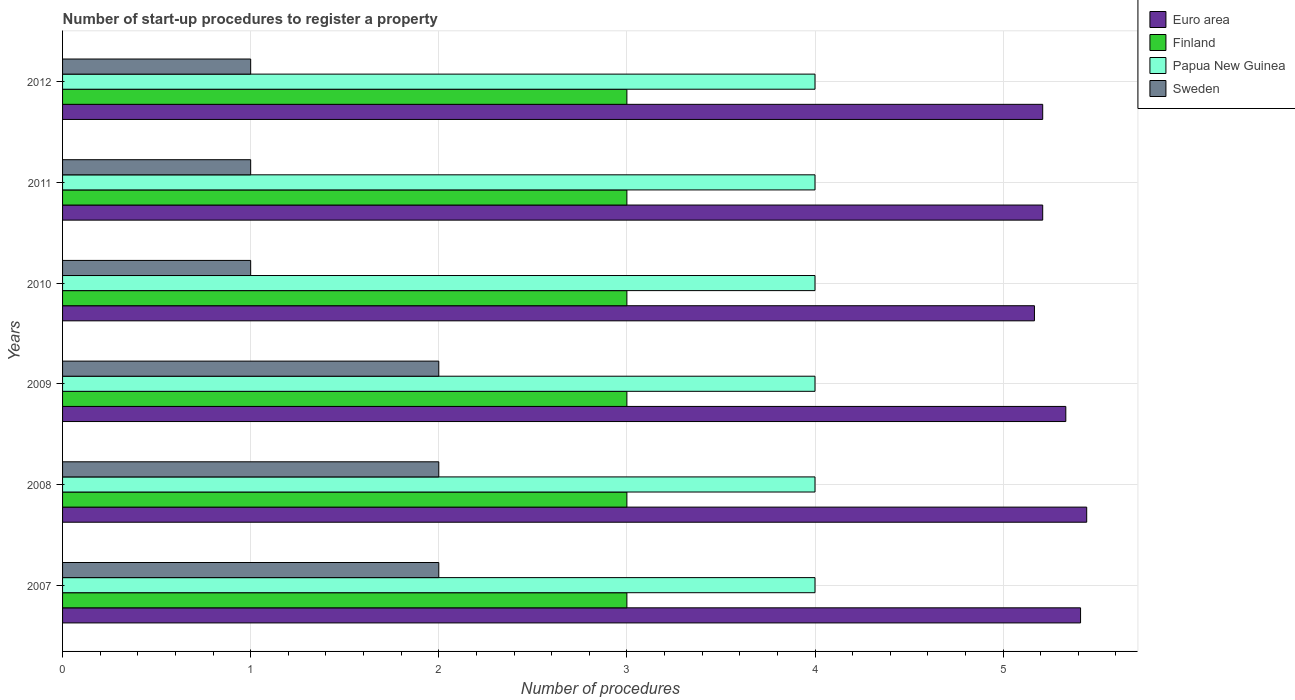How many groups of bars are there?
Make the answer very short. 6. In how many cases, is the number of bars for a given year not equal to the number of legend labels?
Keep it short and to the point. 0. What is the number of procedures required to register a property in Euro area in 2009?
Give a very brief answer. 5.33. Across all years, what is the maximum number of procedures required to register a property in Papua New Guinea?
Provide a succinct answer. 4. Across all years, what is the minimum number of procedures required to register a property in Papua New Guinea?
Your answer should be very brief. 4. In which year was the number of procedures required to register a property in Finland maximum?
Make the answer very short. 2007. What is the total number of procedures required to register a property in Finland in the graph?
Your response must be concise. 18. What is the difference between the number of procedures required to register a property in Sweden in 2010 and the number of procedures required to register a property in Papua New Guinea in 2009?
Your answer should be compact. -3. What is the average number of procedures required to register a property in Euro area per year?
Your response must be concise. 5.3. In the year 2012, what is the difference between the number of procedures required to register a property in Papua New Guinea and number of procedures required to register a property in Finland?
Your answer should be compact. 1. Is the difference between the number of procedures required to register a property in Papua New Guinea in 2008 and 2012 greater than the difference between the number of procedures required to register a property in Finland in 2008 and 2012?
Make the answer very short. No. What is the difference between the highest and the lowest number of procedures required to register a property in Papua New Guinea?
Offer a very short reply. 0. In how many years, is the number of procedures required to register a property in Euro area greater than the average number of procedures required to register a property in Euro area taken over all years?
Give a very brief answer. 3. What does the 3rd bar from the top in 2011 represents?
Provide a short and direct response. Finland. What does the 2nd bar from the bottom in 2012 represents?
Make the answer very short. Finland. Is it the case that in every year, the sum of the number of procedures required to register a property in Sweden and number of procedures required to register a property in Euro area is greater than the number of procedures required to register a property in Finland?
Offer a terse response. Yes. Are all the bars in the graph horizontal?
Your answer should be compact. Yes. How many years are there in the graph?
Offer a very short reply. 6. What is the difference between two consecutive major ticks on the X-axis?
Make the answer very short. 1. Does the graph contain grids?
Provide a short and direct response. Yes. How many legend labels are there?
Your response must be concise. 4. How are the legend labels stacked?
Ensure brevity in your answer.  Vertical. What is the title of the graph?
Offer a terse response. Number of start-up procedures to register a property. What is the label or title of the X-axis?
Give a very brief answer. Number of procedures. What is the Number of procedures of Euro area in 2007?
Your response must be concise. 5.41. What is the Number of procedures in Papua New Guinea in 2007?
Keep it short and to the point. 4. What is the Number of procedures in Euro area in 2008?
Your answer should be very brief. 5.44. What is the Number of procedures in Sweden in 2008?
Keep it short and to the point. 2. What is the Number of procedures in Euro area in 2009?
Provide a short and direct response. 5.33. What is the Number of procedures in Finland in 2009?
Keep it short and to the point. 3. What is the Number of procedures of Papua New Guinea in 2009?
Provide a succinct answer. 4. What is the Number of procedures in Sweden in 2009?
Ensure brevity in your answer.  2. What is the Number of procedures in Euro area in 2010?
Offer a terse response. 5.17. What is the Number of procedures in Finland in 2010?
Your answer should be compact. 3. What is the Number of procedures of Papua New Guinea in 2010?
Provide a short and direct response. 4. What is the Number of procedures in Sweden in 2010?
Offer a very short reply. 1. What is the Number of procedures of Euro area in 2011?
Keep it short and to the point. 5.21. What is the Number of procedures in Papua New Guinea in 2011?
Make the answer very short. 4. What is the Number of procedures of Sweden in 2011?
Ensure brevity in your answer.  1. What is the Number of procedures in Euro area in 2012?
Your response must be concise. 5.21. What is the Number of procedures in Finland in 2012?
Your answer should be compact. 3. What is the Number of procedures in Papua New Guinea in 2012?
Your response must be concise. 4. Across all years, what is the maximum Number of procedures in Euro area?
Make the answer very short. 5.44. Across all years, what is the maximum Number of procedures in Finland?
Your response must be concise. 3. Across all years, what is the maximum Number of procedures in Sweden?
Provide a short and direct response. 2. Across all years, what is the minimum Number of procedures in Euro area?
Your answer should be very brief. 5.17. Across all years, what is the minimum Number of procedures in Finland?
Give a very brief answer. 3. Across all years, what is the minimum Number of procedures in Sweden?
Provide a succinct answer. 1. What is the total Number of procedures in Euro area in the graph?
Ensure brevity in your answer.  31.78. What is the total Number of procedures in Papua New Guinea in the graph?
Provide a succinct answer. 24. What is the total Number of procedures in Sweden in the graph?
Provide a succinct answer. 9. What is the difference between the Number of procedures of Euro area in 2007 and that in 2008?
Your answer should be compact. -0.03. What is the difference between the Number of procedures of Finland in 2007 and that in 2008?
Keep it short and to the point. 0. What is the difference between the Number of procedures of Papua New Guinea in 2007 and that in 2008?
Your answer should be compact. 0. What is the difference between the Number of procedures of Euro area in 2007 and that in 2009?
Keep it short and to the point. 0.08. What is the difference between the Number of procedures of Euro area in 2007 and that in 2010?
Your answer should be compact. 0.25. What is the difference between the Number of procedures of Finland in 2007 and that in 2010?
Ensure brevity in your answer.  0. What is the difference between the Number of procedures of Sweden in 2007 and that in 2010?
Your response must be concise. 1. What is the difference between the Number of procedures in Euro area in 2007 and that in 2011?
Ensure brevity in your answer.  0.2. What is the difference between the Number of procedures of Papua New Guinea in 2007 and that in 2011?
Your answer should be very brief. 0. What is the difference between the Number of procedures of Sweden in 2007 and that in 2011?
Make the answer very short. 1. What is the difference between the Number of procedures in Euro area in 2007 and that in 2012?
Provide a short and direct response. 0.2. What is the difference between the Number of procedures in Euro area in 2008 and that in 2009?
Keep it short and to the point. 0.11. What is the difference between the Number of procedures in Finland in 2008 and that in 2009?
Offer a terse response. 0. What is the difference between the Number of procedures of Papua New Guinea in 2008 and that in 2009?
Make the answer very short. 0. What is the difference between the Number of procedures of Sweden in 2008 and that in 2009?
Provide a short and direct response. 0. What is the difference between the Number of procedures in Euro area in 2008 and that in 2010?
Offer a terse response. 0.28. What is the difference between the Number of procedures of Sweden in 2008 and that in 2010?
Your answer should be very brief. 1. What is the difference between the Number of procedures of Euro area in 2008 and that in 2011?
Make the answer very short. 0.23. What is the difference between the Number of procedures in Papua New Guinea in 2008 and that in 2011?
Ensure brevity in your answer.  0. What is the difference between the Number of procedures in Sweden in 2008 and that in 2011?
Make the answer very short. 1. What is the difference between the Number of procedures of Euro area in 2008 and that in 2012?
Your answer should be compact. 0.23. What is the difference between the Number of procedures of Papua New Guinea in 2009 and that in 2010?
Ensure brevity in your answer.  0. What is the difference between the Number of procedures of Euro area in 2009 and that in 2011?
Provide a succinct answer. 0.12. What is the difference between the Number of procedures of Finland in 2009 and that in 2011?
Provide a succinct answer. 0. What is the difference between the Number of procedures of Sweden in 2009 and that in 2011?
Offer a terse response. 1. What is the difference between the Number of procedures in Euro area in 2009 and that in 2012?
Keep it short and to the point. 0.12. What is the difference between the Number of procedures in Finland in 2009 and that in 2012?
Provide a succinct answer. 0. What is the difference between the Number of procedures in Sweden in 2009 and that in 2012?
Provide a succinct answer. 1. What is the difference between the Number of procedures of Euro area in 2010 and that in 2011?
Keep it short and to the point. -0.04. What is the difference between the Number of procedures of Finland in 2010 and that in 2011?
Your response must be concise. 0. What is the difference between the Number of procedures of Papua New Guinea in 2010 and that in 2011?
Provide a succinct answer. 0. What is the difference between the Number of procedures of Euro area in 2010 and that in 2012?
Give a very brief answer. -0.04. What is the difference between the Number of procedures of Finland in 2010 and that in 2012?
Offer a terse response. 0. What is the difference between the Number of procedures in Papua New Guinea in 2010 and that in 2012?
Provide a succinct answer. 0. What is the difference between the Number of procedures in Sweden in 2010 and that in 2012?
Provide a succinct answer. 0. What is the difference between the Number of procedures of Finland in 2011 and that in 2012?
Offer a terse response. 0. What is the difference between the Number of procedures of Papua New Guinea in 2011 and that in 2012?
Ensure brevity in your answer.  0. What is the difference between the Number of procedures of Euro area in 2007 and the Number of procedures of Finland in 2008?
Make the answer very short. 2.41. What is the difference between the Number of procedures in Euro area in 2007 and the Number of procedures in Papua New Guinea in 2008?
Your answer should be compact. 1.41. What is the difference between the Number of procedures in Euro area in 2007 and the Number of procedures in Sweden in 2008?
Give a very brief answer. 3.41. What is the difference between the Number of procedures in Papua New Guinea in 2007 and the Number of procedures in Sweden in 2008?
Ensure brevity in your answer.  2. What is the difference between the Number of procedures in Euro area in 2007 and the Number of procedures in Finland in 2009?
Give a very brief answer. 2.41. What is the difference between the Number of procedures of Euro area in 2007 and the Number of procedures of Papua New Guinea in 2009?
Keep it short and to the point. 1.41. What is the difference between the Number of procedures in Euro area in 2007 and the Number of procedures in Sweden in 2009?
Make the answer very short. 3.41. What is the difference between the Number of procedures in Finland in 2007 and the Number of procedures in Sweden in 2009?
Provide a short and direct response. 1. What is the difference between the Number of procedures in Papua New Guinea in 2007 and the Number of procedures in Sweden in 2009?
Your response must be concise. 2. What is the difference between the Number of procedures in Euro area in 2007 and the Number of procedures in Finland in 2010?
Offer a terse response. 2.41. What is the difference between the Number of procedures in Euro area in 2007 and the Number of procedures in Papua New Guinea in 2010?
Offer a very short reply. 1.41. What is the difference between the Number of procedures of Euro area in 2007 and the Number of procedures of Sweden in 2010?
Ensure brevity in your answer.  4.41. What is the difference between the Number of procedures of Finland in 2007 and the Number of procedures of Papua New Guinea in 2010?
Ensure brevity in your answer.  -1. What is the difference between the Number of procedures of Finland in 2007 and the Number of procedures of Sweden in 2010?
Your answer should be compact. 2. What is the difference between the Number of procedures of Euro area in 2007 and the Number of procedures of Finland in 2011?
Offer a terse response. 2.41. What is the difference between the Number of procedures of Euro area in 2007 and the Number of procedures of Papua New Guinea in 2011?
Give a very brief answer. 1.41. What is the difference between the Number of procedures of Euro area in 2007 and the Number of procedures of Sweden in 2011?
Make the answer very short. 4.41. What is the difference between the Number of procedures in Finland in 2007 and the Number of procedures in Sweden in 2011?
Offer a very short reply. 2. What is the difference between the Number of procedures of Euro area in 2007 and the Number of procedures of Finland in 2012?
Provide a short and direct response. 2.41. What is the difference between the Number of procedures of Euro area in 2007 and the Number of procedures of Papua New Guinea in 2012?
Provide a succinct answer. 1.41. What is the difference between the Number of procedures in Euro area in 2007 and the Number of procedures in Sweden in 2012?
Your response must be concise. 4.41. What is the difference between the Number of procedures in Euro area in 2008 and the Number of procedures in Finland in 2009?
Keep it short and to the point. 2.44. What is the difference between the Number of procedures of Euro area in 2008 and the Number of procedures of Papua New Guinea in 2009?
Ensure brevity in your answer.  1.44. What is the difference between the Number of procedures of Euro area in 2008 and the Number of procedures of Sweden in 2009?
Give a very brief answer. 3.44. What is the difference between the Number of procedures of Finland in 2008 and the Number of procedures of Sweden in 2009?
Ensure brevity in your answer.  1. What is the difference between the Number of procedures in Euro area in 2008 and the Number of procedures in Finland in 2010?
Your answer should be compact. 2.44. What is the difference between the Number of procedures of Euro area in 2008 and the Number of procedures of Papua New Guinea in 2010?
Give a very brief answer. 1.44. What is the difference between the Number of procedures of Euro area in 2008 and the Number of procedures of Sweden in 2010?
Provide a succinct answer. 4.44. What is the difference between the Number of procedures of Papua New Guinea in 2008 and the Number of procedures of Sweden in 2010?
Keep it short and to the point. 3. What is the difference between the Number of procedures of Euro area in 2008 and the Number of procedures of Finland in 2011?
Give a very brief answer. 2.44. What is the difference between the Number of procedures of Euro area in 2008 and the Number of procedures of Papua New Guinea in 2011?
Ensure brevity in your answer.  1.44. What is the difference between the Number of procedures in Euro area in 2008 and the Number of procedures in Sweden in 2011?
Your response must be concise. 4.44. What is the difference between the Number of procedures in Finland in 2008 and the Number of procedures in Papua New Guinea in 2011?
Give a very brief answer. -1. What is the difference between the Number of procedures of Euro area in 2008 and the Number of procedures of Finland in 2012?
Make the answer very short. 2.44. What is the difference between the Number of procedures in Euro area in 2008 and the Number of procedures in Papua New Guinea in 2012?
Offer a very short reply. 1.44. What is the difference between the Number of procedures of Euro area in 2008 and the Number of procedures of Sweden in 2012?
Your answer should be very brief. 4.44. What is the difference between the Number of procedures of Finland in 2008 and the Number of procedures of Sweden in 2012?
Your answer should be compact. 2. What is the difference between the Number of procedures in Papua New Guinea in 2008 and the Number of procedures in Sweden in 2012?
Your answer should be compact. 3. What is the difference between the Number of procedures of Euro area in 2009 and the Number of procedures of Finland in 2010?
Make the answer very short. 2.33. What is the difference between the Number of procedures of Euro area in 2009 and the Number of procedures of Papua New Guinea in 2010?
Provide a succinct answer. 1.33. What is the difference between the Number of procedures of Euro area in 2009 and the Number of procedures of Sweden in 2010?
Provide a short and direct response. 4.33. What is the difference between the Number of procedures of Finland in 2009 and the Number of procedures of Papua New Guinea in 2010?
Provide a short and direct response. -1. What is the difference between the Number of procedures of Finland in 2009 and the Number of procedures of Sweden in 2010?
Provide a short and direct response. 2. What is the difference between the Number of procedures of Papua New Guinea in 2009 and the Number of procedures of Sweden in 2010?
Give a very brief answer. 3. What is the difference between the Number of procedures in Euro area in 2009 and the Number of procedures in Finland in 2011?
Provide a succinct answer. 2.33. What is the difference between the Number of procedures of Euro area in 2009 and the Number of procedures of Papua New Guinea in 2011?
Your response must be concise. 1.33. What is the difference between the Number of procedures of Euro area in 2009 and the Number of procedures of Sweden in 2011?
Your answer should be compact. 4.33. What is the difference between the Number of procedures in Euro area in 2009 and the Number of procedures in Finland in 2012?
Provide a succinct answer. 2.33. What is the difference between the Number of procedures in Euro area in 2009 and the Number of procedures in Papua New Guinea in 2012?
Your answer should be compact. 1.33. What is the difference between the Number of procedures in Euro area in 2009 and the Number of procedures in Sweden in 2012?
Ensure brevity in your answer.  4.33. What is the difference between the Number of procedures in Euro area in 2010 and the Number of procedures in Finland in 2011?
Provide a short and direct response. 2.17. What is the difference between the Number of procedures of Euro area in 2010 and the Number of procedures of Sweden in 2011?
Make the answer very short. 4.17. What is the difference between the Number of procedures of Finland in 2010 and the Number of procedures of Papua New Guinea in 2011?
Your response must be concise. -1. What is the difference between the Number of procedures in Finland in 2010 and the Number of procedures in Sweden in 2011?
Your answer should be compact. 2. What is the difference between the Number of procedures of Euro area in 2010 and the Number of procedures of Finland in 2012?
Provide a succinct answer. 2.17. What is the difference between the Number of procedures of Euro area in 2010 and the Number of procedures of Sweden in 2012?
Make the answer very short. 4.17. What is the difference between the Number of procedures of Papua New Guinea in 2010 and the Number of procedures of Sweden in 2012?
Offer a terse response. 3. What is the difference between the Number of procedures of Euro area in 2011 and the Number of procedures of Finland in 2012?
Provide a succinct answer. 2.21. What is the difference between the Number of procedures in Euro area in 2011 and the Number of procedures in Papua New Guinea in 2012?
Offer a terse response. 1.21. What is the difference between the Number of procedures in Euro area in 2011 and the Number of procedures in Sweden in 2012?
Provide a succinct answer. 4.21. What is the difference between the Number of procedures in Finland in 2011 and the Number of procedures in Papua New Guinea in 2012?
Make the answer very short. -1. What is the difference between the Number of procedures in Finland in 2011 and the Number of procedures in Sweden in 2012?
Make the answer very short. 2. What is the average Number of procedures in Euro area per year?
Provide a short and direct response. 5.3. What is the average Number of procedures of Papua New Guinea per year?
Ensure brevity in your answer.  4. In the year 2007, what is the difference between the Number of procedures in Euro area and Number of procedures in Finland?
Keep it short and to the point. 2.41. In the year 2007, what is the difference between the Number of procedures of Euro area and Number of procedures of Papua New Guinea?
Ensure brevity in your answer.  1.41. In the year 2007, what is the difference between the Number of procedures in Euro area and Number of procedures in Sweden?
Give a very brief answer. 3.41. In the year 2007, what is the difference between the Number of procedures of Finland and Number of procedures of Papua New Guinea?
Offer a terse response. -1. In the year 2008, what is the difference between the Number of procedures in Euro area and Number of procedures in Finland?
Provide a short and direct response. 2.44. In the year 2008, what is the difference between the Number of procedures in Euro area and Number of procedures in Papua New Guinea?
Make the answer very short. 1.44. In the year 2008, what is the difference between the Number of procedures of Euro area and Number of procedures of Sweden?
Ensure brevity in your answer.  3.44. In the year 2008, what is the difference between the Number of procedures of Finland and Number of procedures of Papua New Guinea?
Provide a succinct answer. -1. In the year 2008, what is the difference between the Number of procedures in Papua New Guinea and Number of procedures in Sweden?
Make the answer very short. 2. In the year 2009, what is the difference between the Number of procedures in Euro area and Number of procedures in Finland?
Provide a succinct answer. 2.33. In the year 2009, what is the difference between the Number of procedures in Euro area and Number of procedures in Papua New Guinea?
Offer a terse response. 1.33. In the year 2009, what is the difference between the Number of procedures in Finland and Number of procedures in Papua New Guinea?
Offer a terse response. -1. In the year 2009, what is the difference between the Number of procedures of Finland and Number of procedures of Sweden?
Your response must be concise. 1. In the year 2009, what is the difference between the Number of procedures of Papua New Guinea and Number of procedures of Sweden?
Your answer should be very brief. 2. In the year 2010, what is the difference between the Number of procedures of Euro area and Number of procedures of Finland?
Your answer should be very brief. 2.17. In the year 2010, what is the difference between the Number of procedures of Euro area and Number of procedures of Papua New Guinea?
Ensure brevity in your answer.  1.17. In the year 2010, what is the difference between the Number of procedures in Euro area and Number of procedures in Sweden?
Provide a short and direct response. 4.17. In the year 2010, what is the difference between the Number of procedures in Finland and Number of procedures in Papua New Guinea?
Your response must be concise. -1. In the year 2011, what is the difference between the Number of procedures in Euro area and Number of procedures in Finland?
Make the answer very short. 2.21. In the year 2011, what is the difference between the Number of procedures in Euro area and Number of procedures in Papua New Guinea?
Provide a short and direct response. 1.21. In the year 2011, what is the difference between the Number of procedures in Euro area and Number of procedures in Sweden?
Your answer should be very brief. 4.21. In the year 2011, what is the difference between the Number of procedures of Papua New Guinea and Number of procedures of Sweden?
Keep it short and to the point. 3. In the year 2012, what is the difference between the Number of procedures in Euro area and Number of procedures in Finland?
Your answer should be very brief. 2.21. In the year 2012, what is the difference between the Number of procedures in Euro area and Number of procedures in Papua New Guinea?
Your response must be concise. 1.21. In the year 2012, what is the difference between the Number of procedures in Euro area and Number of procedures in Sweden?
Keep it short and to the point. 4.21. In the year 2012, what is the difference between the Number of procedures in Finland and Number of procedures in Papua New Guinea?
Offer a very short reply. -1. In the year 2012, what is the difference between the Number of procedures in Finland and Number of procedures in Sweden?
Give a very brief answer. 2. What is the ratio of the Number of procedures of Papua New Guinea in 2007 to that in 2008?
Your answer should be compact. 1. What is the ratio of the Number of procedures of Sweden in 2007 to that in 2008?
Keep it short and to the point. 1. What is the ratio of the Number of procedures in Euro area in 2007 to that in 2009?
Your answer should be compact. 1.01. What is the ratio of the Number of procedures in Finland in 2007 to that in 2009?
Your answer should be compact. 1. What is the ratio of the Number of procedures of Papua New Guinea in 2007 to that in 2009?
Ensure brevity in your answer.  1. What is the ratio of the Number of procedures of Euro area in 2007 to that in 2010?
Offer a terse response. 1.05. What is the ratio of the Number of procedures in Papua New Guinea in 2007 to that in 2010?
Offer a very short reply. 1. What is the ratio of the Number of procedures of Euro area in 2007 to that in 2011?
Provide a succinct answer. 1.04. What is the ratio of the Number of procedures of Papua New Guinea in 2007 to that in 2011?
Ensure brevity in your answer.  1. What is the ratio of the Number of procedures of Sweden in 2007 to that in 2011?
Provide a short and direct response. 2. What is the ratio of the Number of procedures in Euro area in 2007 to that in 2012?
Make the answer very short. 1.04. What is the ratio of the Number of procedures in Papua New Guinea in 2007 to that in 2012?
Offer a terse response. 1. What is the ratio of the Number of procedures of Sweden in 2007 to that in 2012?
Your response must be concise. 2. What is the ratio of the Number of procedures of Euro area in 2008 to that in 2009?
Give a very brief answer. 1.02. What is the ratio of the Number of procedures of Finland in 2008 to that in 2009?
Keep it short and to the point. 1. What is the ratio of the Number of procedures of Papua New Guinea in 2008 to that in 2009?
Ensure brevity in your answer.  1. What is the ratio of the Number of procedures in Sweden in 2008 to that in 2009?
Keep it short and to the point. 1. What is the ratio of the Number of procedures of Euro area in 2008 to that in 2010?
Provide a succinct answer. 1.05. What is the ratio of the Number of procedures of Finland in 2008 to that in 2010?
Ensure brevity in your answer.  1. What is the ratio of the Number of procedures of Euro area in 2008 to that in 2011?
Provide a succinct answer. 1.04. What is the ratio of the Number of procedures of Sweden in 2008 to that in 2011?
Your answer should be compact. 2. What is the ratio of the Number of procedures of Euro area in 2008 to that in 2012?
Make the answer very short. 1.04. What is the ratio of the Number of procedures in Sweden in 2008 to that in 2012?
Your response must be concise. 2. What is the ratio of the Number of procedures of Euro area in 2009 to that in 2010?
Offer a terse response. 1.03. What is the ratio of the Number of procedures of Sweden in 2009 to that in 2010?
Keep it short and to the point. 2. What is the ratio of the Number of procedures of Euro area in 2009 to that in 2011?
Provide a succinct answer. 1.02. What is the ratio of the Number of procedures in Finland in 2009 to that in 2011?
Ensure brevity in your answer.  1. What is the ratio of the Number of procedures in Papua New Guinea in 2009 to that in 2011?
Your response must be concise. 1. What is the ratio of the Number of procedures in Sweden in 2009 to that in 2011?
Provide a short and direct response. 2. What is the ratio of the Number of procedures in Euro area in 2009 to that in 2012?
Give a very brief answer. 1.02. What is the ratio of the Number of procedures in Sweden in 2010 to that in 2011?
Provide a succinct answer. 1. What is the ratio of the Number of procedures of Papua New Guinea in 2010 to that in 2012?
Keep it short and to the point. 1. What is the ratio of the Number of procedures of Sweden in 2010 to that in 2012?
Provide a succinct answer. 1. What is the ratio of the Number of procedures of Finland in 2011 to that in 2012?
Keep it short and to the point. 1. What is the ratio of the Number of procedures of Papua New Guinea in 2011 to that in 2012?
Provide a short and direct response. 1. What is the ratio of the Number of procedures in Sweden in 2011 to that in 2012?
Provide a succinct answer. 1. What is the difference between the highest and the second highest Number of procedures of Euro area?
Provide a short and direct response. 0.03. What is the difference between the highest and the second highest Number of procedures in Papua New Guinea?
Give a very brief answer. 0. What is the difference between the highest and the second highest Number of procedures in Sweden?
Make the answer very short. 0. What is the difference between the highest and the lowest Number of procedures in Euro area?
Offer a very short reply. 0.28. What is the difference between the highest and the lowest Number of procedures of Finland?
Your answer should be compact. 0. What is the difference between the highest and the lowest Number of procedures in Sweden?
Make the answer very short. 1. 